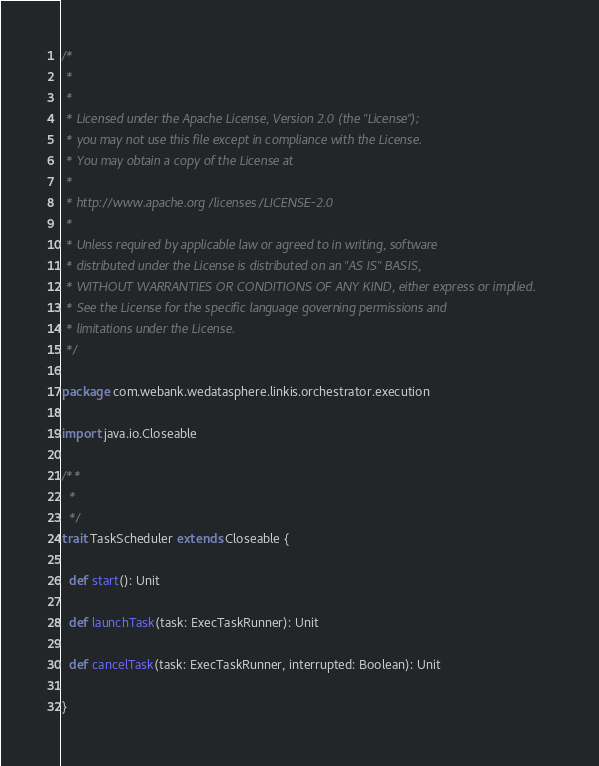Convert code to text. <code><loc_0><loc_0><loc_500><loc_500><_Scala_>/*
 *
 *
 * Licensed under the Apache License, Version 2.0 (the "License");
 * you may not use this file except in compliance with the License.
 * You may obtain a copy of the License at
 *
 * http://www.apache.org/licenses/LICENSE-2.0
 *
 * Unless required by applicable law or agreed to in writing, software
 * distributed under the License is distributed on an "AS IS" BASIS,
 * WITHOUT WARRANTIES OR CONDITIONS OF ANY KIND, either express or implied.
 * See the License for the specific language governing permissions and
 * limitations under the License.
 */

package com.webank.wedatasphere.linkis.orchestrator.execution

import java.io.Closeable

/**
  *
  */
trait TaskScheduler extends Closeable {

  def start(): Unit

  def launchTask(task: ExecTaskRunner): Unit

  def cancelTask(task: ExecTaskRunner, interrupted: Boolean): Unit

}</code> 